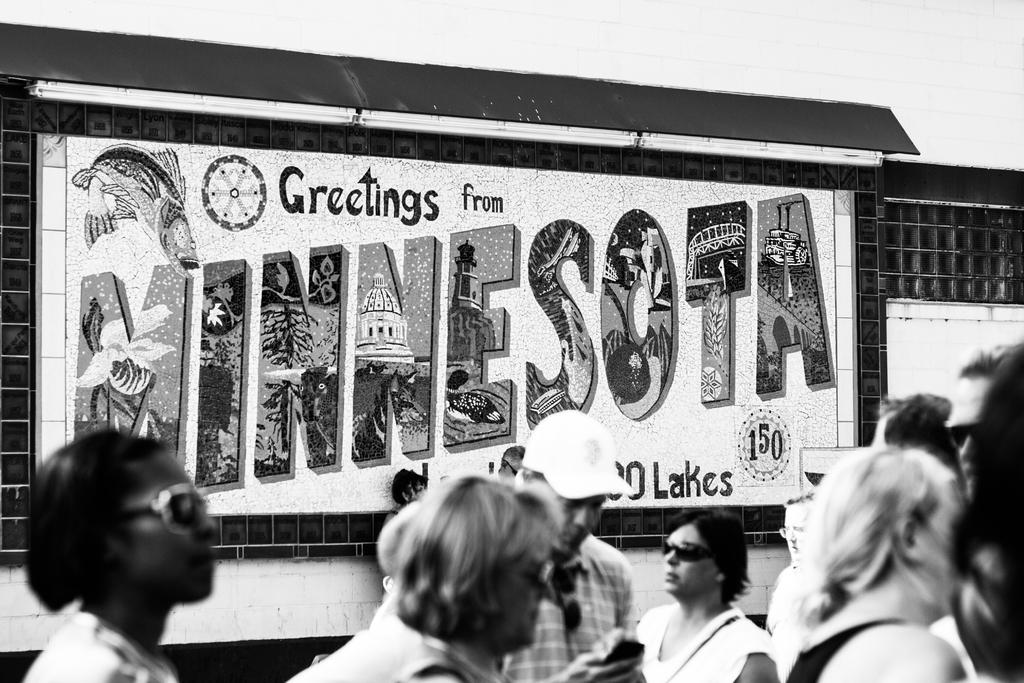What is happening in the image? There are people standing in the image. What can be seen in the background? There is a board visible in the background. What is written on the board? Something is written on the board, but we cannot determine the content from the image. What is the color scheme of the image? The image is in black and white. What type of drug is being burned by the giraffe in the image? There is no giraffe or drug present in the image. 